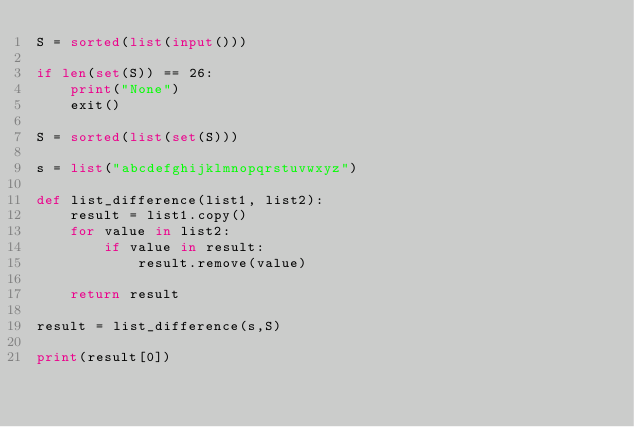<code> <loc_0><loc_0><loc_500><loc_500><_Python_>S = sorted(list(input()))

if len(set(S)) == 26:
    print("None")
    exit()

S = sorted(list(set(S)))

s = list("abcdefghijklmnopqrstuvwxyz")

def list_difference(list1, list2):
    result = list1.copy()
    for value in list2:
        if value in result:
            result.remove(value)

    return result

result = list_difference(s,S)

print(result[0])</code> 